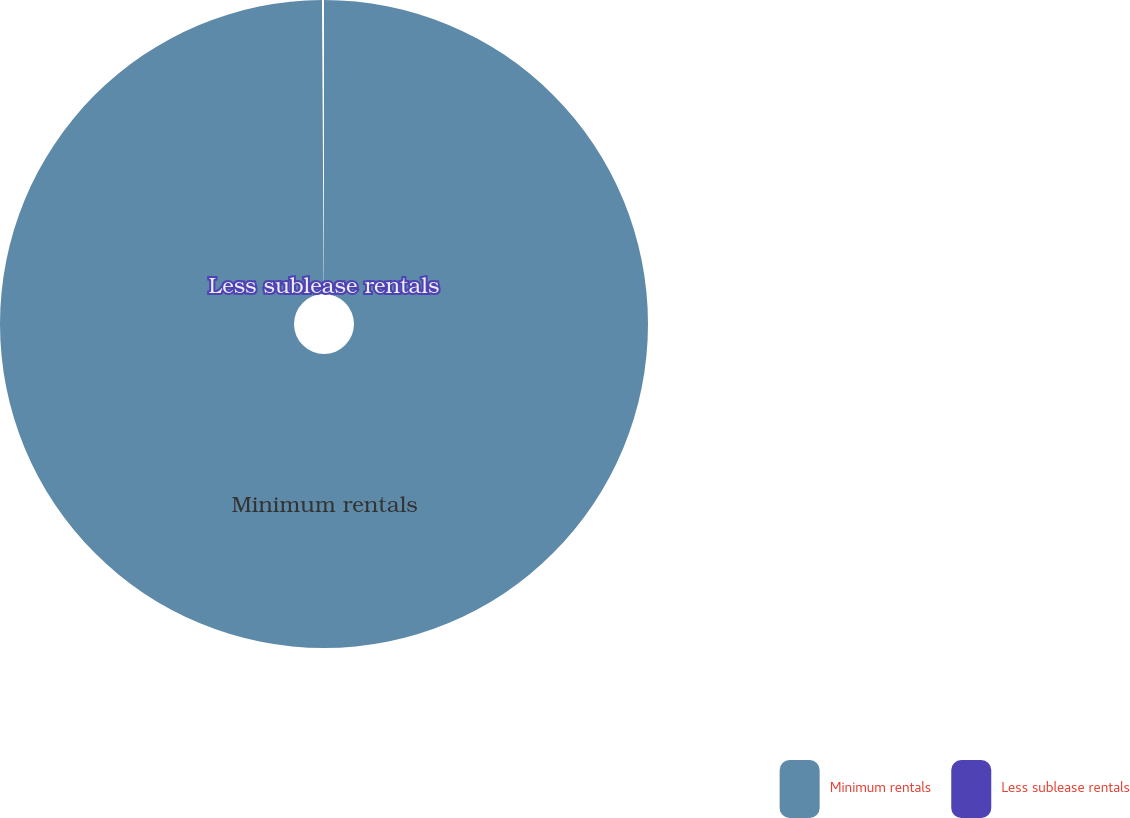Convert chart. <chart><loc_0><loc_0><loc_500><loc_500><pie_chart><fcel>Minimum rentals<fcel>Less sublease rentals<nl><fcel>99.9%<fcel>0.1%<nl></chart> 